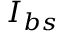<formula> <loc_0><loc_0><loc_500><loc_500>I _ { b s }</formula> 